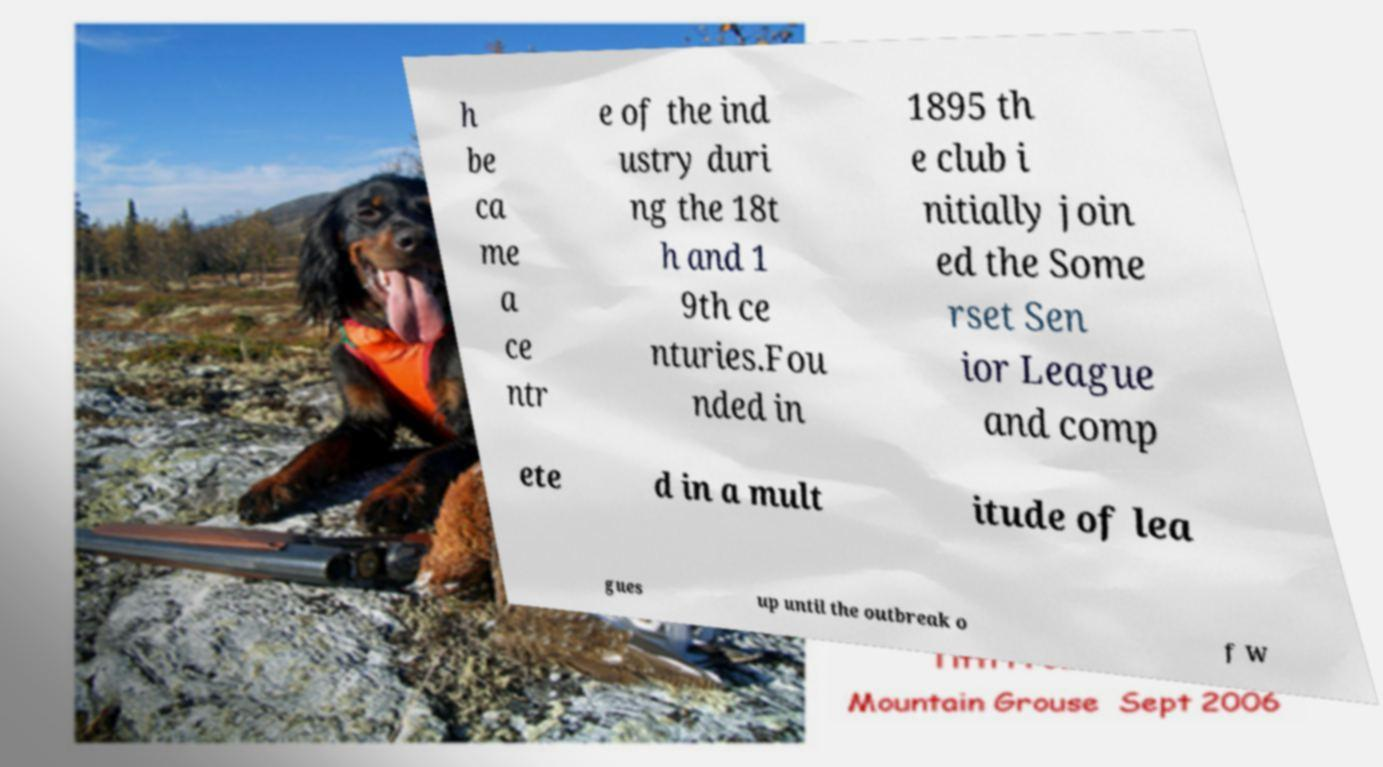For documentation purposes, I need the text within this image transcribed. Could you provide that? h be ca me a ce ntr e of the ind ustry duri ng the 18t h and 1 9th ce nturies.Fou nded in 1895 th e club i nitially join ed the Some rset Sen ior League and comp ete d in a mult itude of lea gues up until the outbreak o f W 